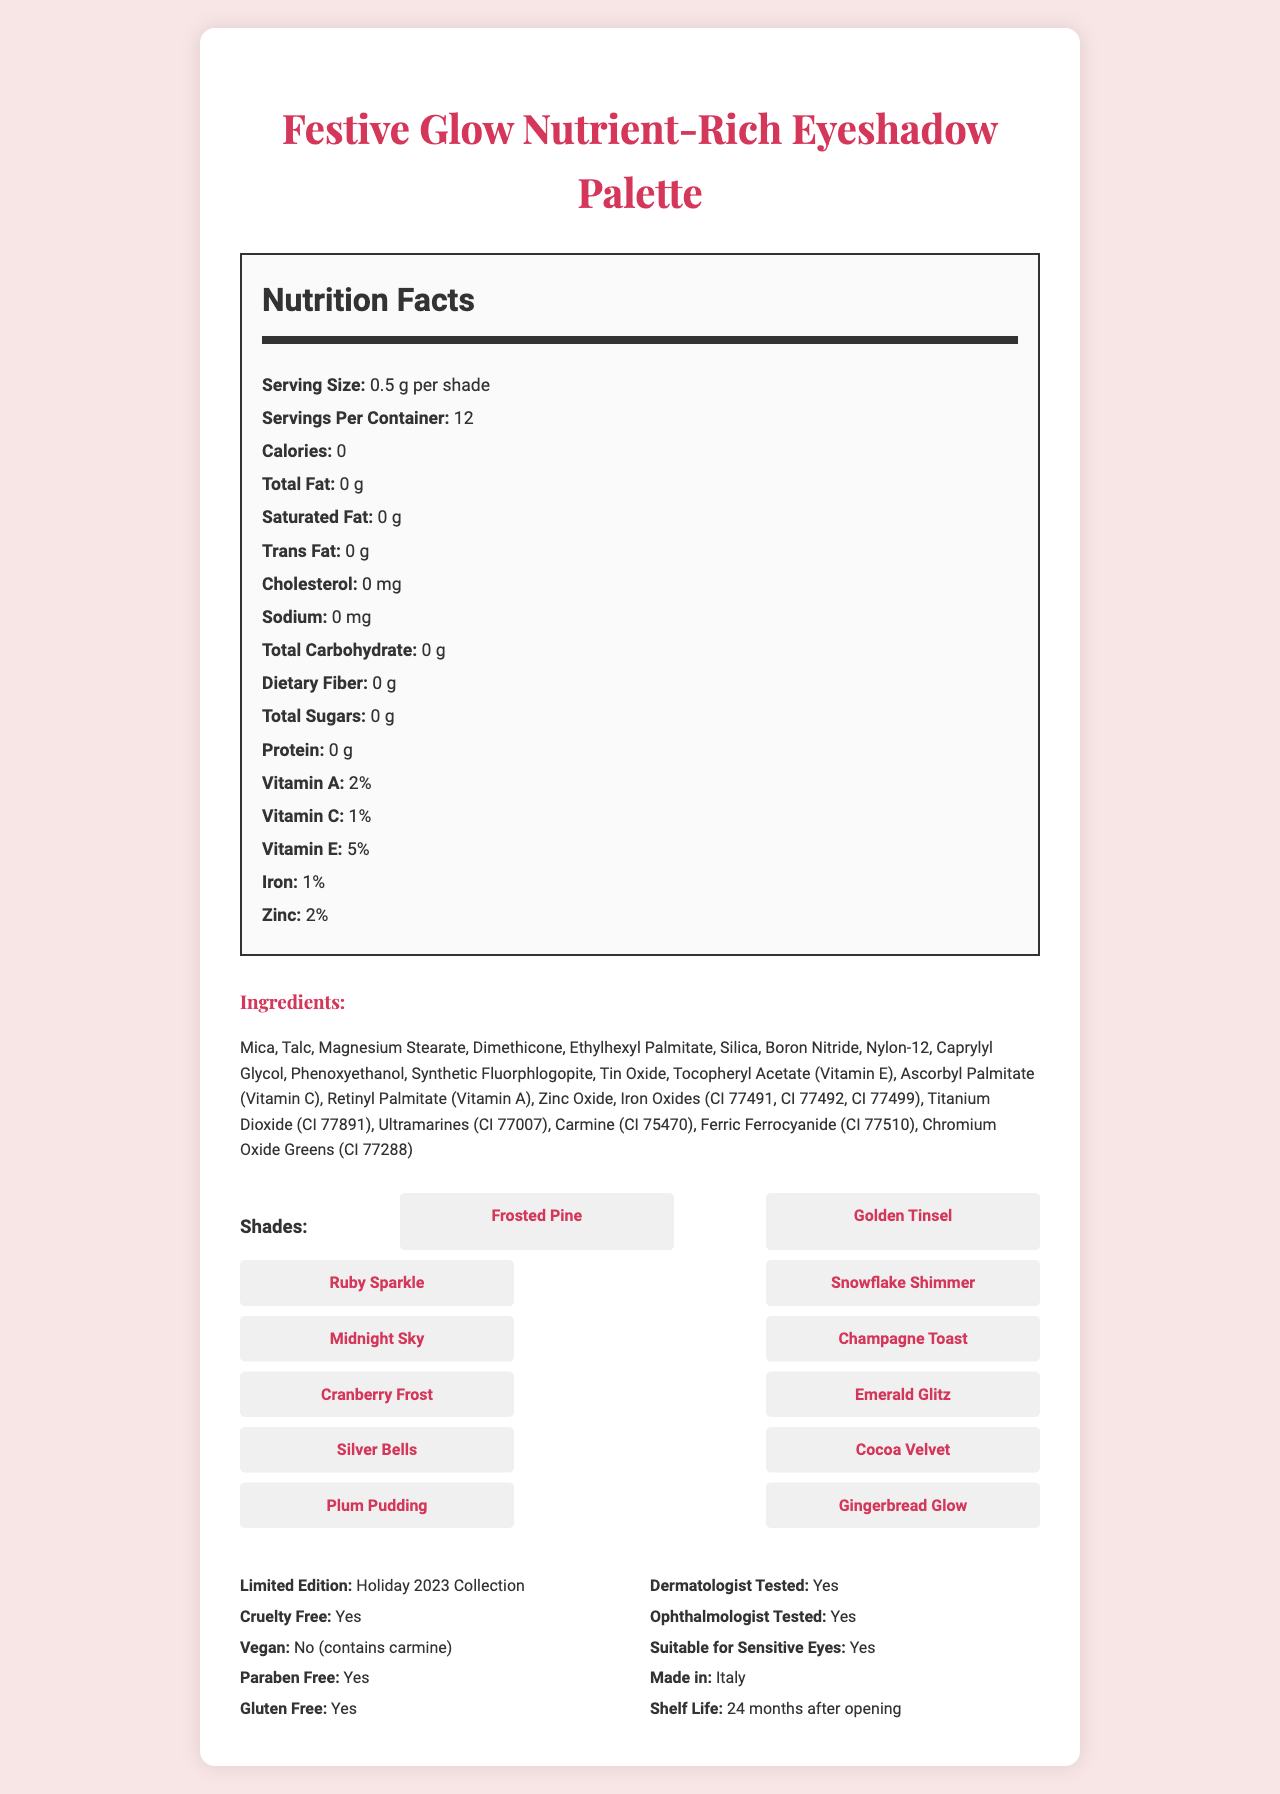what is the serving size for each shade? The document states that the serving size for each shade is 0.5 g.
Answer: 0.5 g how many servings are in the container? The document mentions there are 12 servings per container.
Answer: 12 are there any calories in the eyeshadow palette? The document lists the calories as 0.
Answer: No what are the main ingredients in the eyeshadow palette? The ingredients listed in the document include Mica, Talc, Magnesium Stearate, among others.
Answer: Mica, Talc, Magnesium Stearate, Dimethicone, Ethylhexyl Palmitate, Silica, Boron Nitride, Nylon-12, Caprylyl Glycol, Phenoxyethanol, Synthetic Fluorphlogopite, Tin Oxide, Tocopheryl Acetate, Ascorbyl Palmitate, Retinyl Palmitate, Zinc Oxide, Iron Oxides, Titanium Dioxide, Ultramarines, Carmine, Ferric Ferrocyanide, Chromium Oxide Greens what vitamins are present in this eyeshadow palette? The document lists Vitamin A (2%), Vitamin C (1%), and Vitamin E (5%) as present in the product.
Answer: Vitamin A, Vitamin C, Vitamin E which shade has a festive shimmer suitable for a holiday look? A. Cocoa Velvet B. Snowflake Shimmer C. Plum Pudding "Snowflake Shimmer" explicitly suggests a festive and shimmery quality suitable for a holiday look.
Answer: B. Snowflake Shimmer is this product cruelty-free? The document specifies that the product is cruelty-free.
Answer: Yes can this eyeshadow palette be used by someone with sensitive eyes? The document states that the product is suitable for sensitive eyes.
Answer: Yes where is the eyeshadow palette manufactured? The document mentions that the product is made in Italy.
Answer: Italy is the product vegan? The document states that the product is not vegan because it contains carmine.
Answer: No how long is the shelf life of this eyeshadow palette? The document mentions a shelf life of 24 months after opening.
Answer: 24 months after opening how many total shades are in the palette? The document lists 12 different shades.
Answer: 12 which of the following is NOT one of the shades? I. Ruby Sparkle II. Golden Glow III. Emerald Glitz The document lists "Ruby Sparkle" and "Emerald Glitz" as shades but not "Golden Glow".
Answer: II. Golden Glow is the palette suitable for someone with gluten sensitivity? The document states that the product is gluten-free.
Answer: Yes does the eyeshadow palette contain any sugar? The nutritional label indicates that the total sugars are 0 g.
Answer: No summarize the main features of the Festive Glow Nutrient-Rich Eyeshadow Palette. The document describes the product's key attributes, including nutritional content, ingredients, shade names, and additional certifications and features.
Answer: Festive Glow Nutrient-Rich Eyeshadow Palette is a limited-edition holiday collection featuring 12 shades with nutrient-rich pigments. It is cruelty-free, paraben-free, and gluten-free but not vegan. It is dermatologically and ophthalmologically tested, suitable for sensitive eyes, made in Italy, and has a 24-month shelf life after opening. The product contains vitamins A, C, and E but has no calories, fats, carbohydrates, sugars, or proteins. what percentage of Vitamin D does the product contain? The document does not provide information about Vitamin D.
Answer: I don't know 